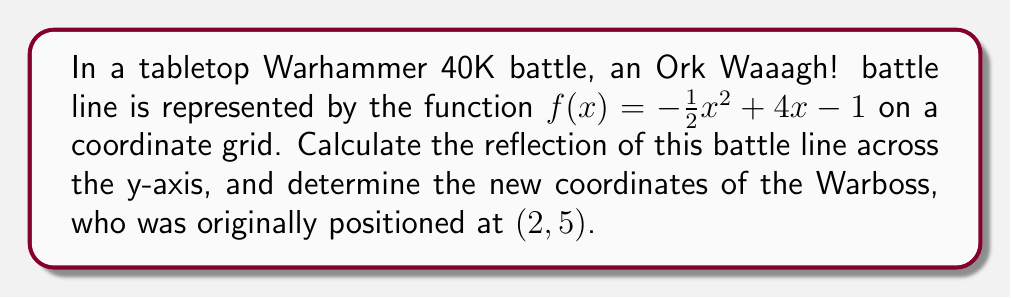Provide a solution to this math problem. To reflect the Ork Waaagh! battle line across the y-axis, we need to follow these steps:

1) The general rule for reflecting a function $f(x)$ across the y-axis is to replace every $x$ with $-x$. This gives us the new function $f(-x)$.

2) Apply this rule to our original function:
   $f(x) = -\frac{1}{2}x^2 + 4x - 1$
   becomes
   $f(-x) = -\frac{1}{2}(-x)^2 + 4(-x) - 1$

3) Simplify:
   $f(-x) = -\frac{1}{2}x^2 - 4x - 1$

This is our new function representing the reflected Ork Waaagh! battle line.

4) For the Warboss position, we need to reflect the x-coordinate across the y-axis while keeping the y-coordinate the same. The rule for this is $(a, b)$ becomes $(-a, b)$.

5) The original position was $(2, 5)$, so the new position will be $(-2, 5)$.

To verify this, we can plug $x=-2$ into our new function:

$f(-2) = -\frac{1}{2}(-2)^2 - 4(-2) - 1$
$= -\frac{1}{2}(4) + 8 - 1$
$= -2 + 8 - 1$
$= 5$

This confirms that the point $(-2, 5)$ lies on our reflected function.
Answer: The reflected Ork Waaagh! battle line is represented by the function $f(x) = -\frac{1}{2}x^2 - 4x - 1$, and the new position of the Warboss is $(-2, 5)$. 